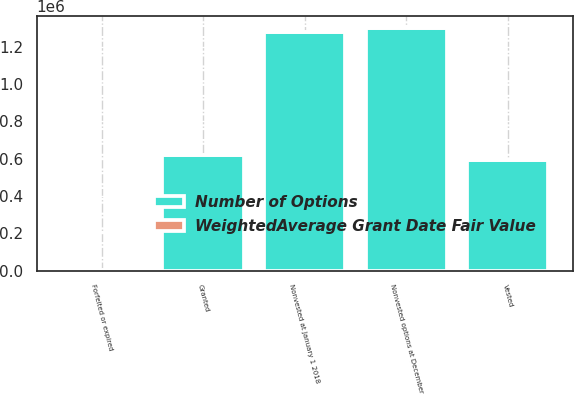Convert chart to OTSL. <chart><loc_0><loc_0><loc_500><loc_500><stacked_bar_chart><ecel><fcel>Nonvested at January 1 2018<fcel>Granted<fcel>Vested<fcel>Forfeited or expired<fcel>Nonvested options at December<nl><fcel>Number of Options<fcel>1.2786e+06<fcel>619700<fcel>594300<fcel>5200<fcel>1.2988e+06<nl><fcel>WeightedAverage Grant Date Fair Value<fcel>11.82<fcel>15.9<fcel>12.1<fcel>12.74<fcel>13.63<nl></chart> 